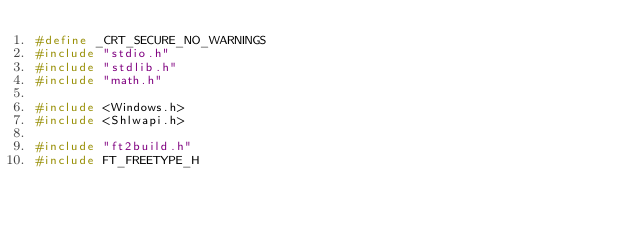<code> <loc_0><loc_0><loc_500><loc_500><_C++_>#define _CRT_SECURE_NO_WARNINGS
#include "stdio.h"
#include "stdlib.h"
#include "math.h"

#include <Windows.h>
#include <Shlwapi.h>

#include "ft2build.h"
#include FT_FREETYPE_H
</code> 